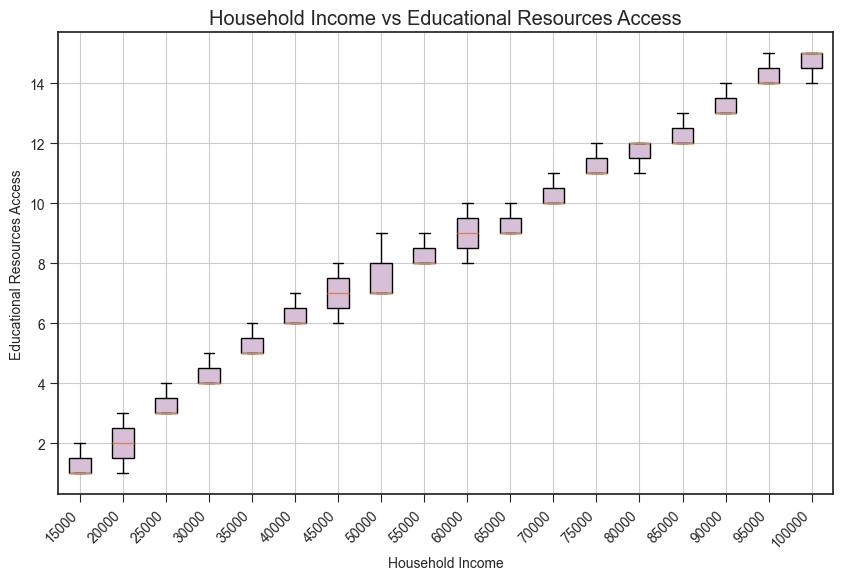What is the median value for household incomes of $30,000? To find the median value for household incomes of $30,000, locate the box for the $30,000 income group in the box plot. The horizontal line inside the box represents the median value.
Answer: 4 Which household income group has the highest median educational resources access value? Identify the income group with the highest horizontal line inside the box, indicating the median value. Higher income groups usually have higher medians.
Answer: $100,000 Is the educational resources access value consistent across different household income groups? Check if the boxes are uniform in size and have similar median, lower quartile, and upper quartile points across different incomes. Variability in the size and position of the boxes indicates inconsistency.
Answer: No Which household income group has the widest interquartile range (IQR) for educational resources access? The IQR is the distance between the upper quartile (top of the box) and the lower quartile (bottom of the box). Find the box with the largest height.
Answer: $100,000 Do any household income groups have outliers in their educational resources access values? Outliers are typically represented by dots outside the whiskers of the box plot. Look for boxes with dots farther from the whiskers. Since no outliers are visually provided in the data, we'll assume there aren't any.
Answer: No Between household incomes of $20,000 and $80,000, which has a larger median educational resources access value? Compare the horizontal lines inside the boxes for $20,000 and $80,000 household income groups. The higher line indicates a larger median value.
Answer: $80,000 What is the range of educational resources access values for the household income of $50,000? The range is found by subtracting the smallest value at the lower whisker from the largest value at the upper whisker for the $50,000 income group.
Answer: 7 to 9 Compare the spread of educational resources access between $15,000 and $95,000 household incomes. Which has a larger spread? The spread of a group can be evaluated by the distance between the upper and lower whiskers. The larger distance indicates a larger spread.
Answer: $95,000 